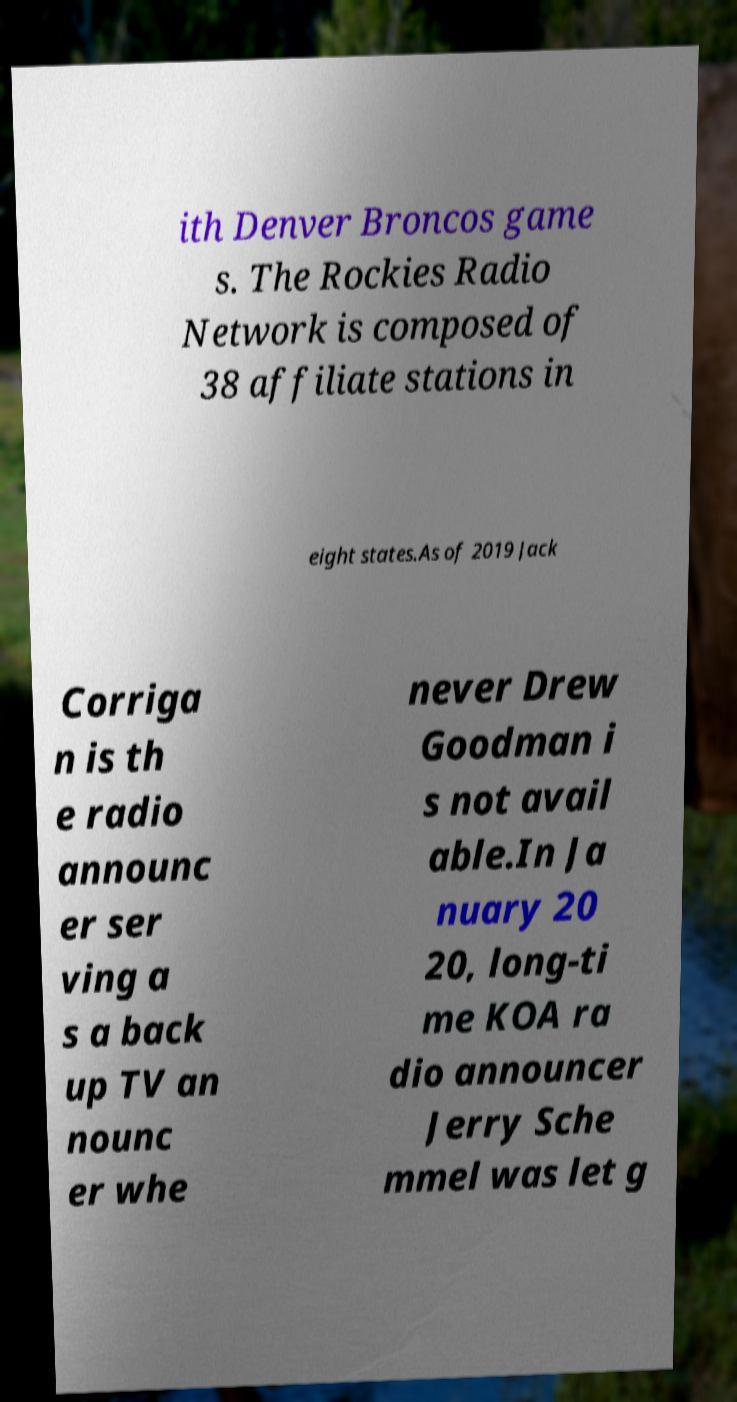Can you accurately transcribe the text from the provided image for me? ith Denver Broncos game s. The Rockies Radio Network is composed of 38 affiliate stations in eight states.As of 2019 Jack Corriga n is th e radio announc er ser ving a s a back up TV an nounc er whe never Drew Goodman i s not avail able.In Ja nuary 20 20, long-ti me KOA ra dio announcer Jerry Sche mmel was let g 